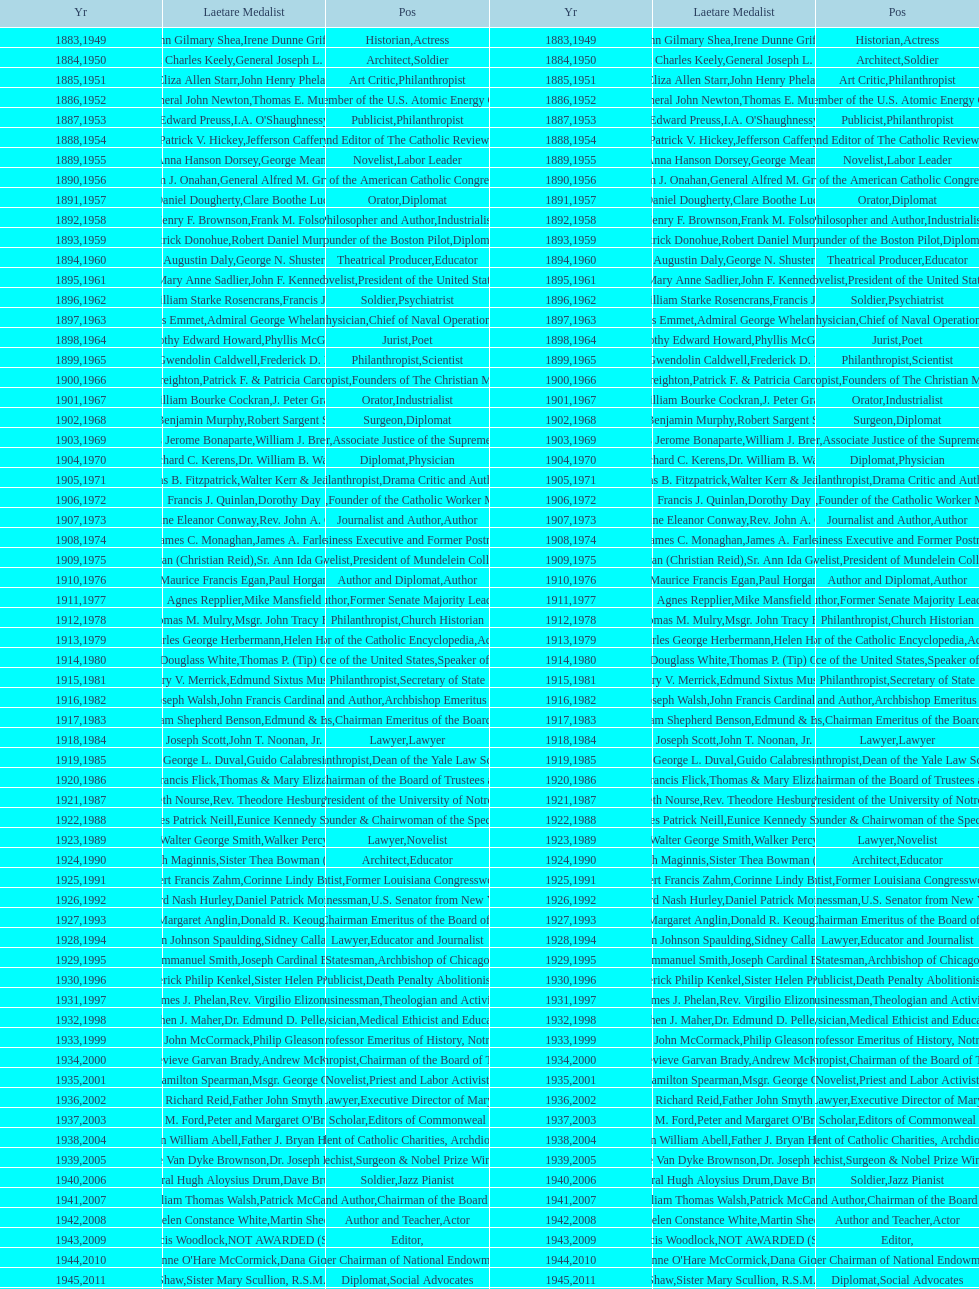How many people are or were involved in journalism? 5. 